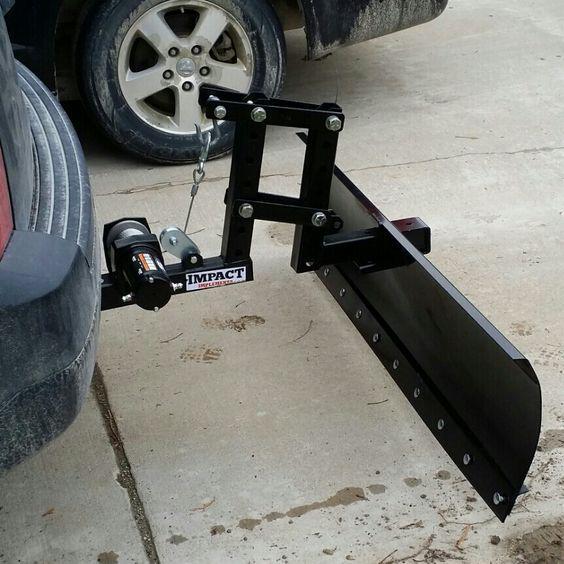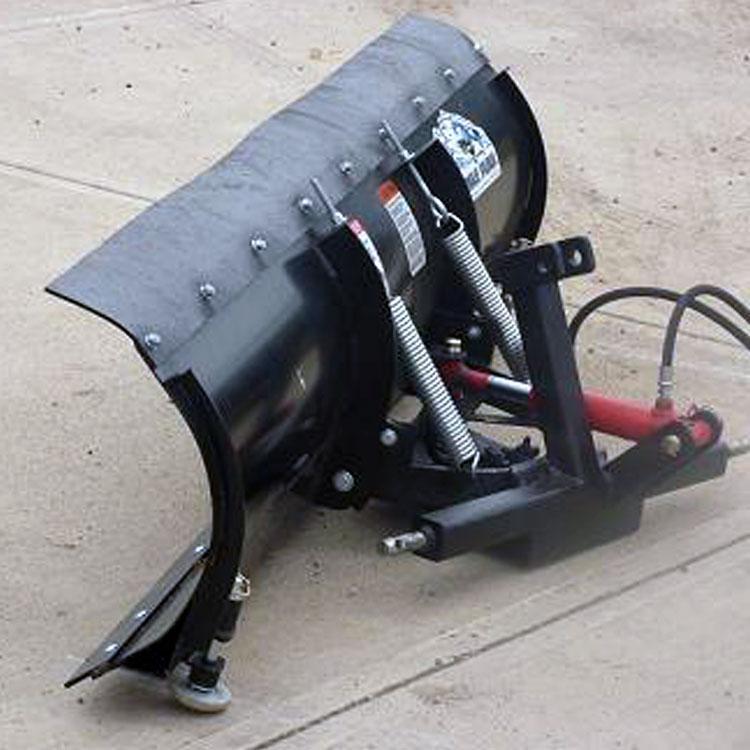The first image is the image on the left, the second image is the image on the right. For the images displayed, is the sentence "In one image, a black snowplow blade is attached to the front of a vehicle." factually correct? Answer yes or no. Yes. The first image is the image on the left, the second image is the image on the right. Analyze the images presented: Is the assertion "The photo on the right shows a snow plow that is not connected to a vehicle and lying on pavement." valid? Answer yes or no. Yes. 